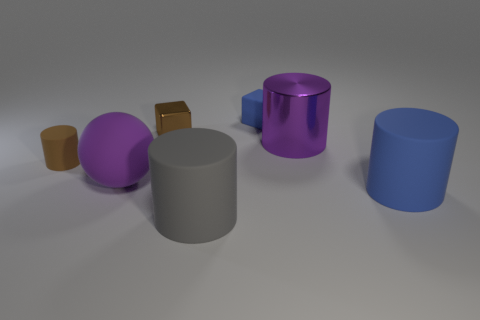Subtract all cyan cylinders. Subtract all red balls. How many cylinders are left? 4 Add 1 gray metal objects. How many objects exist? 8 Subtract all cylinders. How many objects are left? 3 Subtract 0 green cylinders. How many objects are left? 7 Subtract all matte cylinders. Subtract all tiny gray metallic cylinders. How many objects are left? 4 Add 7 large spheres. How many large spheres are left? 8 Add 2 brown rubber cylinders. How many brown rubber cylinders exist? 3 